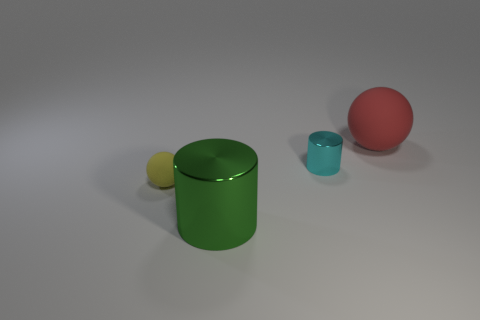Is the sphere left of the large red rubber ball made of the same material as the large object that is in front of the big rubber ball?
Offer a very short reply. No. Is there a big red object behind the matte sphere in front of the matte ball that is behind the tiny yellow matte sphere?
Make the answer very short. Yes. What number of big things are red matte objects or metal things?
Your response must be concise. 2. What is the color of the rubber ball that is the same size as the cyan cylinder?
Offer a very short reply. Yellow. There is a big green cylinder; what number of cyan things are behind it?
Provide a succinct answer. 1. Are there any large green things that have the same material as the cyan cylinder?
Provide a short and direct response. Yes. The metallic object behind the large shiny cylinder is what color?
Provide a succinct answer. Cyan. Are there an equal number of tiny cyan cylinders right of the small cyan cylinder and big green things in front of the big rubber object?
Provide a succinct answer. No. There is a big object to the right of the cylinder behind the large green cylinder; what is its material?
Your answer should be very brief. Rubber. What number of objects are large cyan cylinders or metal things to the right of the big green object?
Offer a terse response. 1. 